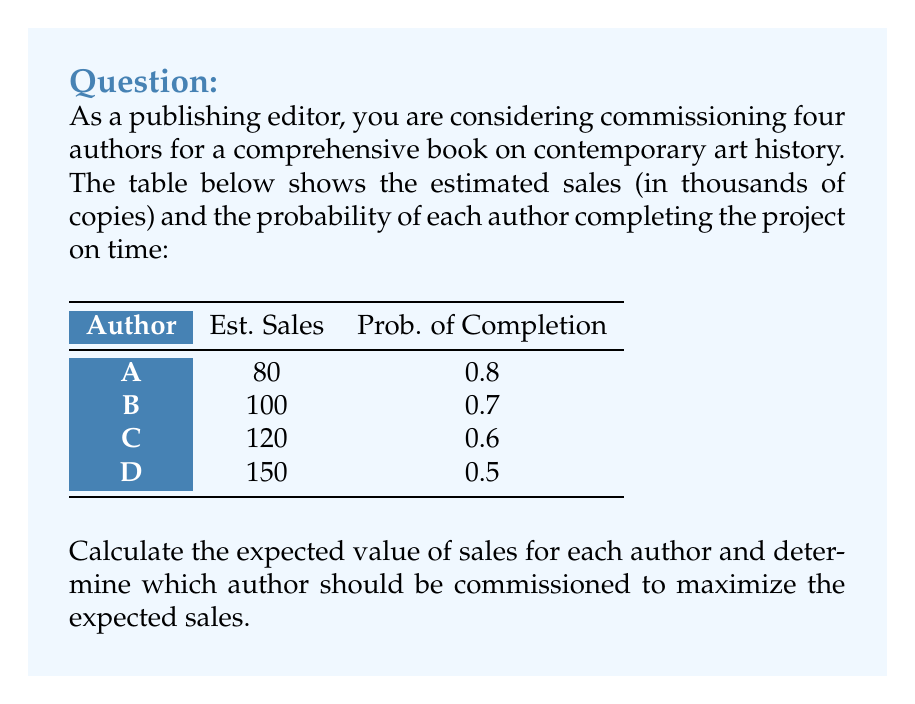Can you answer this question? To solve this problem, we need to calculate the expected value of sales for each author using the formula:

$$ E(\text{Sales}) = \text{Estimated Sales} \times \text{Probability of Completion} $$

Let's calculate for each author:

1. Author A:
   $$ E(A) = 80,000 \times 0.8 = 64,000 $$

2. Author B:
   $$ E(B) = 100,000 \times 0.7 = 70,000 $$

3. Author C:
   $$ E(C) = 120,000 \times 0.6 = 72,000 $$

4. Author D:
   $$ E(D) = 150,000 \times 0.5 = 75,000 $$

To maximize the expected sales, we should choose the author with the highest expected value. In this case, Author D has the highest expected value of 75,000 copies.
Answer: Author D should be commissioned with an expected sales of 75,000 copies. 